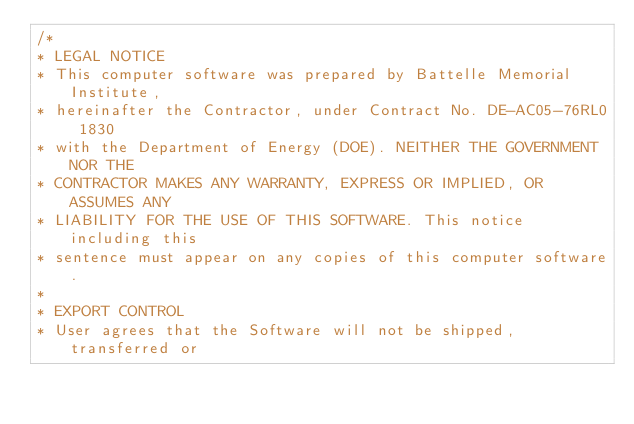<code> <loc_0><loc_0><loc_500><loc_500><_C_>/*
* LEGAL NOTICE
* This computer software was prepared by Battelle Memorial Institute,
* hereinafter the Contractor, under Contract No. DE-AC05-76RL0 1830
* with the Department of Energy (DOE). NEITHER THE GOVERNMENT NOR THE
* CONTRACTOR MAKES ANY WARRANTY, EXPRESS OR IMPLIED, OR ASSUMES ANY
* LIABILITY FOR THE USE OF THIS SOFTWARE. This notice including this
* sentence must appear on any copies of this computer software.
* 
* EXPORT CONTROL
* User agrees that the Software will not be shipped, transferred or</code> 